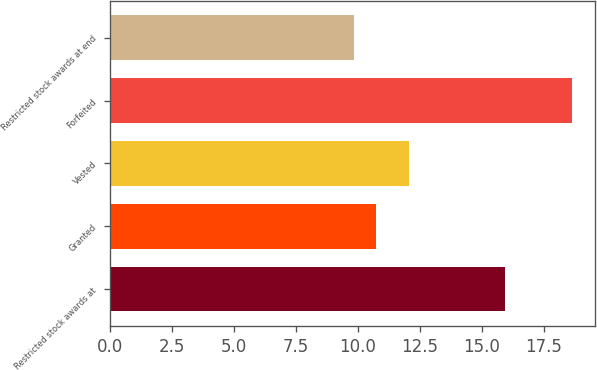Convert chart. <chart><loc_0><loc_0><loc_500><loc_500><bar_chart><fcel>Restricted stock awards at<fcel>Granted<fcel>Vested<fcel>Forfeited<fcel>Restricted stock awards at end<nl><fcel>15.93<fcel>10.72<fcel>12.05<fcel>18.63<fcel>9.84<nl></chart> 